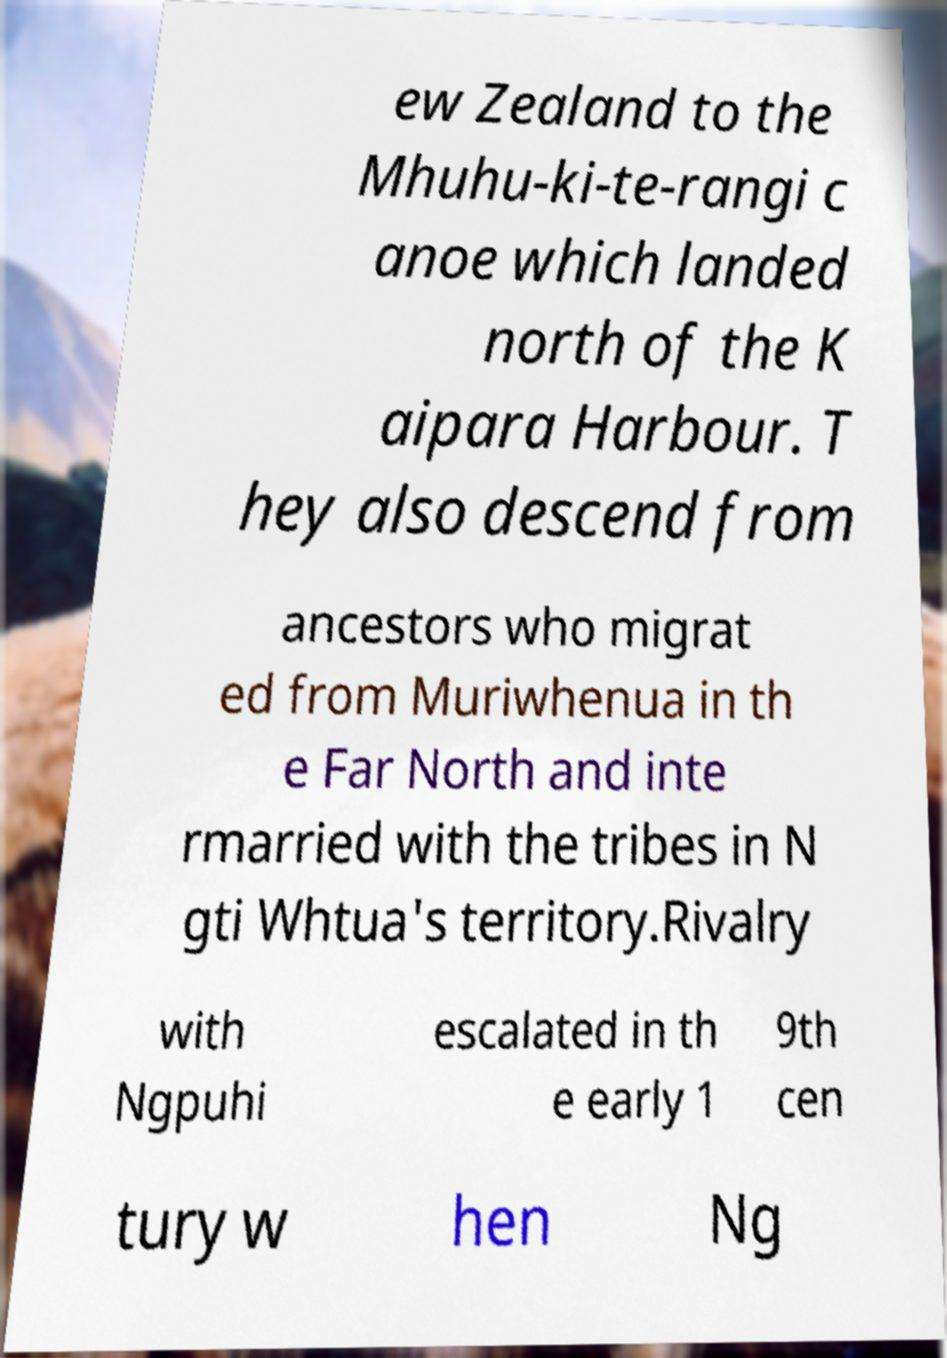Can you accurately transcribe the text from the provided image for me? ew Zealand to the Mhuhu-ki-te-rangi c anoe which landed north of the K aipara Harbour. T hey also descend from ancestors who migrat ed from Muriwhenua in th e Far North and inte rmarried with the tribes in N gti Whtua's territory.Rivalry with Ngpuhi escalated in th e early 1 9th cen tury w hen Ng 